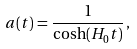<formula> <loc_0><loc_0><loc_500><loc_500>a ( t ) = \frac { 1 } { \cosh ( H _ { 0 } t ) } \, ,</formula> 